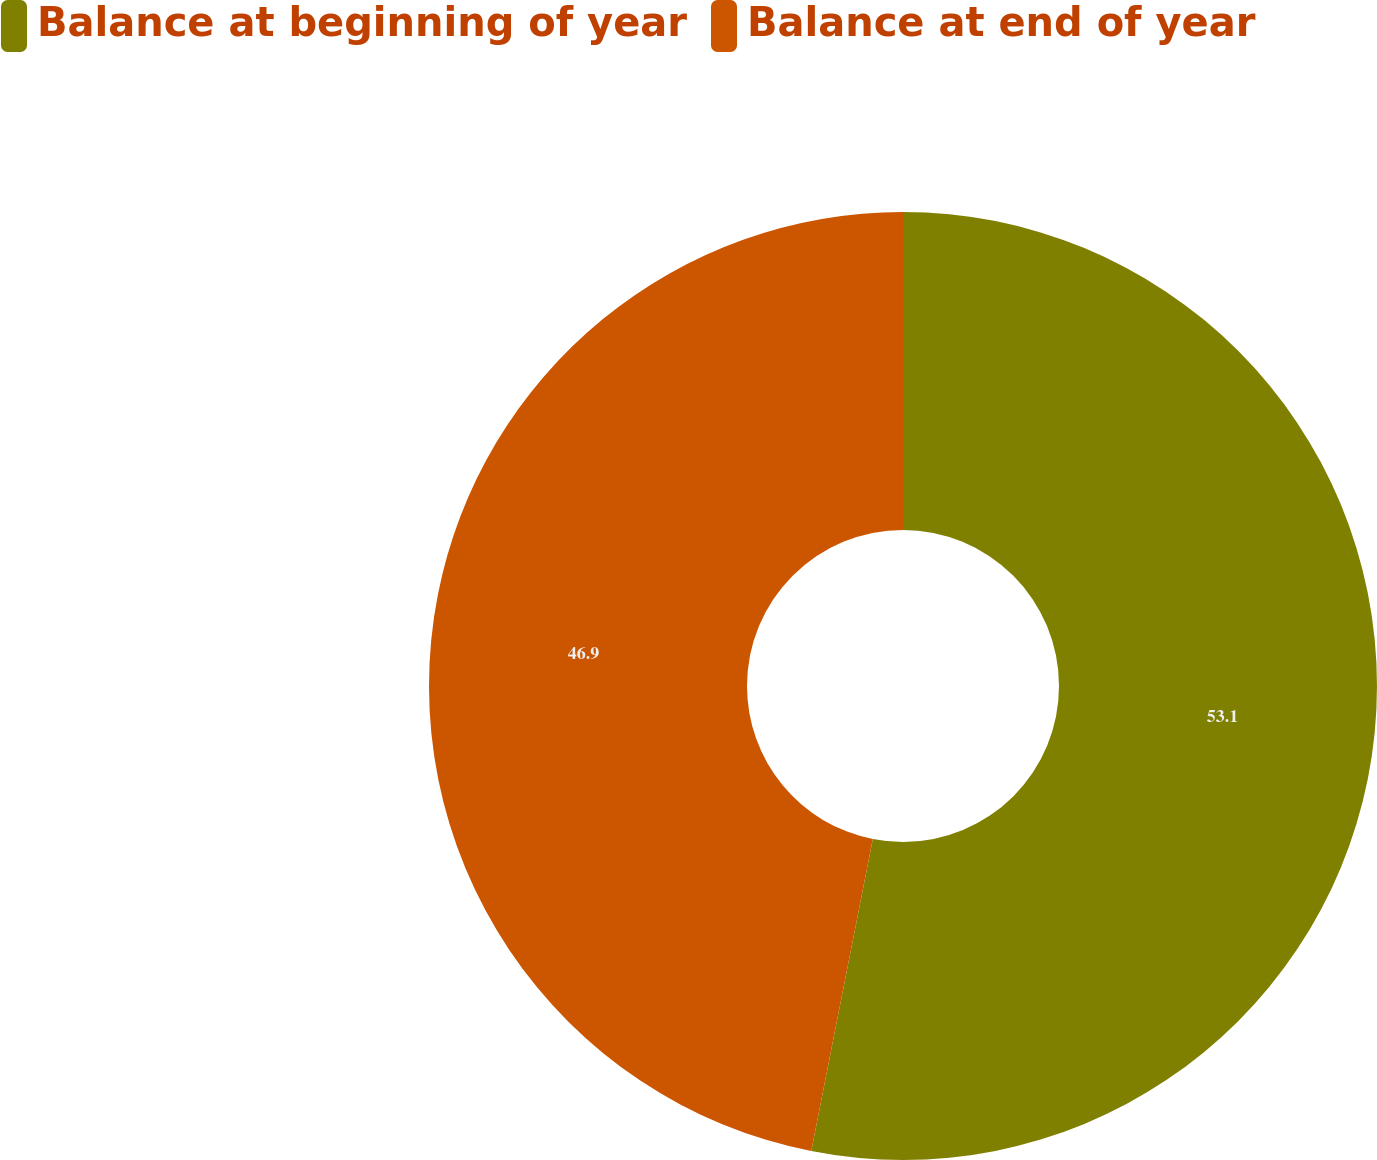Convert chart to OTSL. <chart><loc_0><loc_0><loc_500><loc_500><pie_chart><fcel>Balance at beginning of year<fcel>Balance at end of year<nl><fcel>53.1%<fcel>46.9%<nl></chart> 